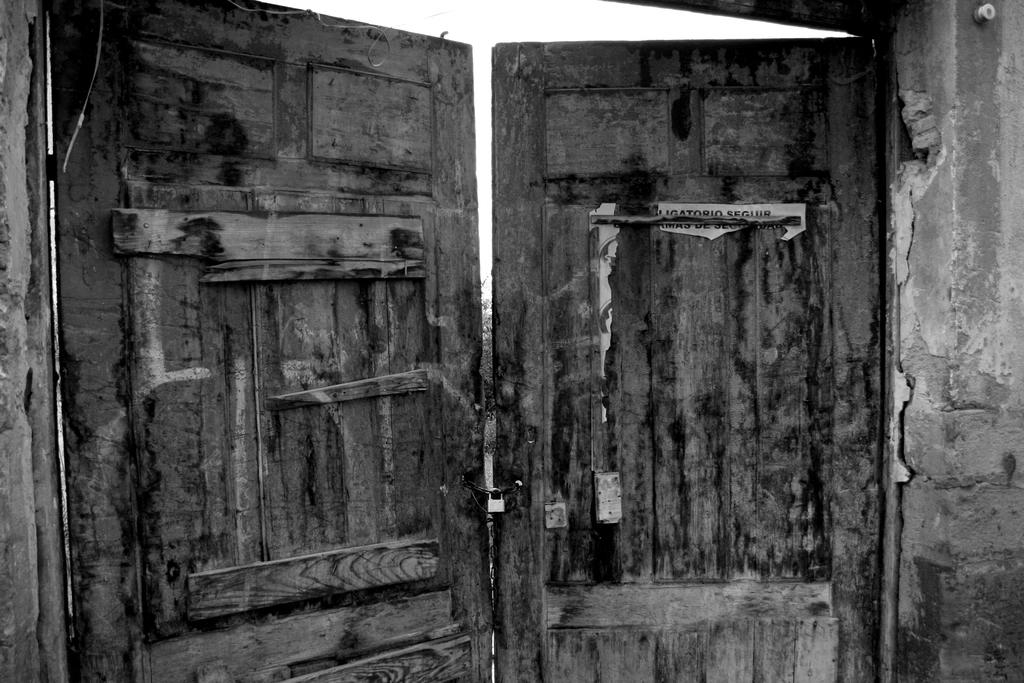What type of doors are featured in the image? There are wooden doors in the image. What security feature is present on the wooden doors? There is a lock on the wooden doors. What can be seen on the right side of the image? There is a wall on the right side of the image. What is visible in the background of the image? The sky is visible in the background of the image. What hobbies are being pursued in the cellar depicted in the image? There is no cellar present in the image, and therefore no hobbies can be observed. What type of destruction is evident in the image? There is no destruction present in the image; it features wooden doors, a lock, a wall, and the sky. 